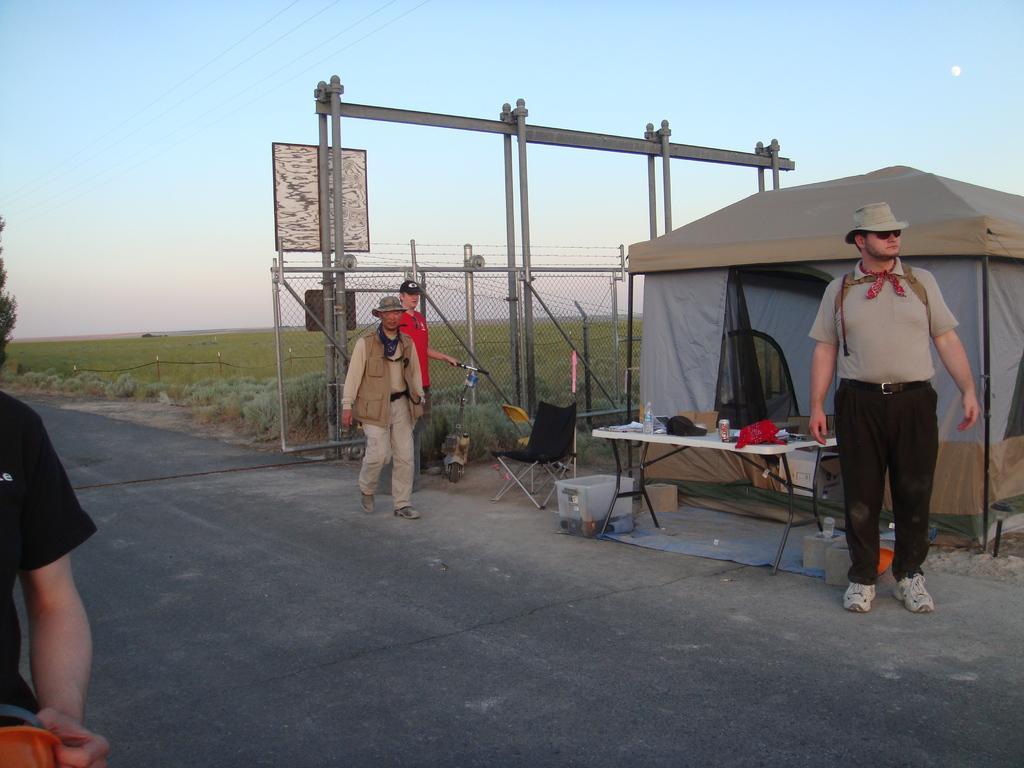How would you summarize this image in a sentence or two? In this image we can see persons standing on the road. In the background we can see tent, table, water bottle, fencing, plants, tree and sky. 